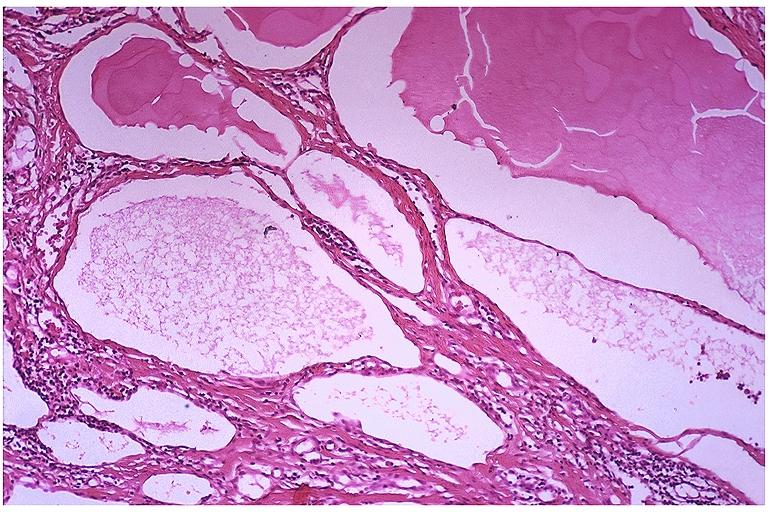does this image show lymphangioma?
Answer the question using a single word or phrase. Yes 